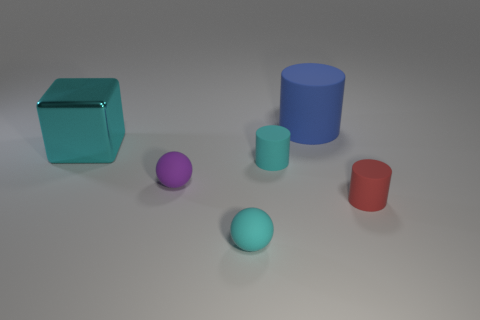Does the small cylinder that is behind the red cylinder have the same color as the large shiny cube that is behind the cyan rubber ball?
Ensure brevity in your answer.  Yes. Are there any rubber cylinders that have the same color as the metallic thing?
Keep it short and to the point. Yes. The big metal object is what color?
Your answer should be very brief. Cyan. What is the size of the blue rubber object right of the cyan matte object behind the small cylinder on the right side of the blue cylinder?
Offer a terse response. Large. How many other things are the same size as the purple object?
Make the answer very short. 3. How many red cylinders are the same material as the big cyan cube?
Offer a terse response. 0. There is a matte object that is in front of the small red rubber cylinder; what shape is it?
Provide a short and direct response. Sphere. Are the big cyan block and the tiny cyan thing in front of the small cyan rubber cylinder made of the same material?
Provide a succinct answer. No. Are any tiny purple matte spheres visible?
Ensure brevity in your answer.  Yes. Is there a cyan thing in front of the tiny cylinder that is left of the rubber object on the right side of the big blue matte thing?
Your answer should be compact. Yes. 